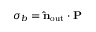Convert formula to latex. <formula><loc_0><loc_0><loc_500><loc_500>\sigma _ { b } = \hat { n } _ { o u t } \cdot P</formula> 